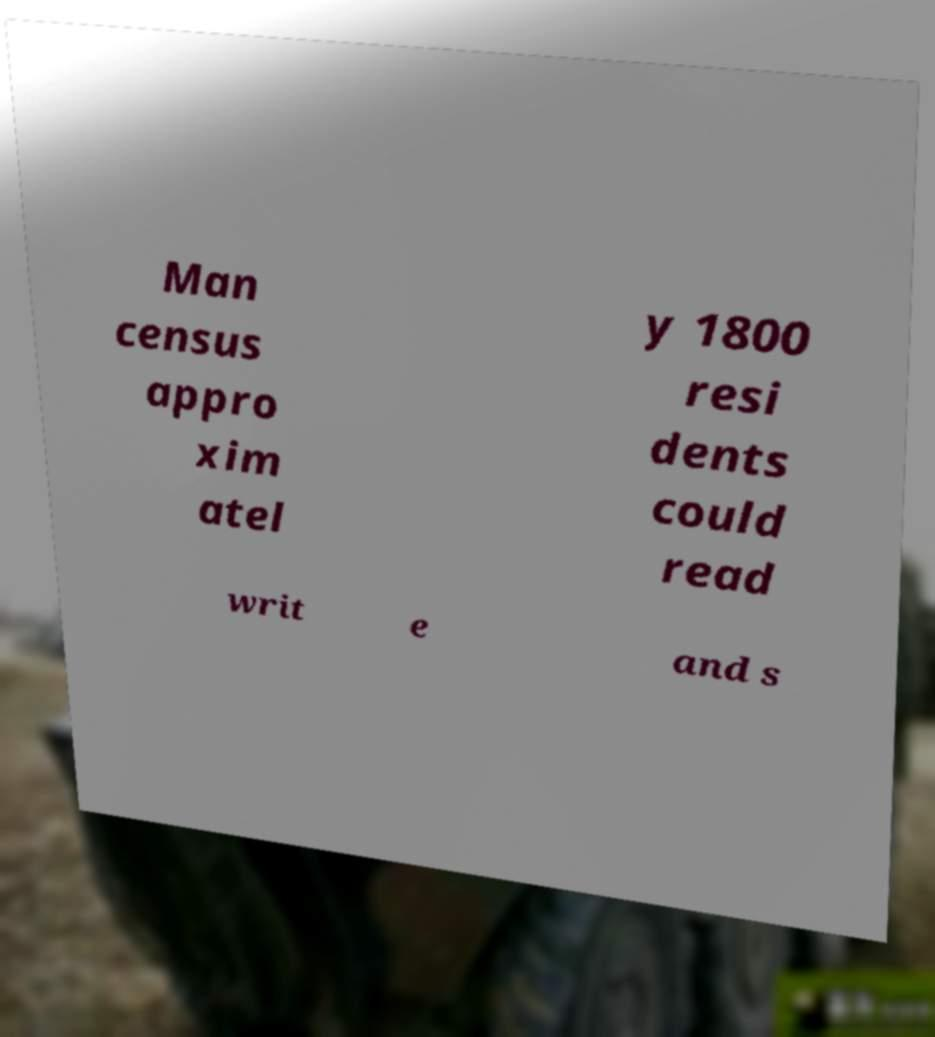Can you accurately transcribe the text from the provided image for me? Man census appro xim atel y 1800 resi dents could read writ e and s 